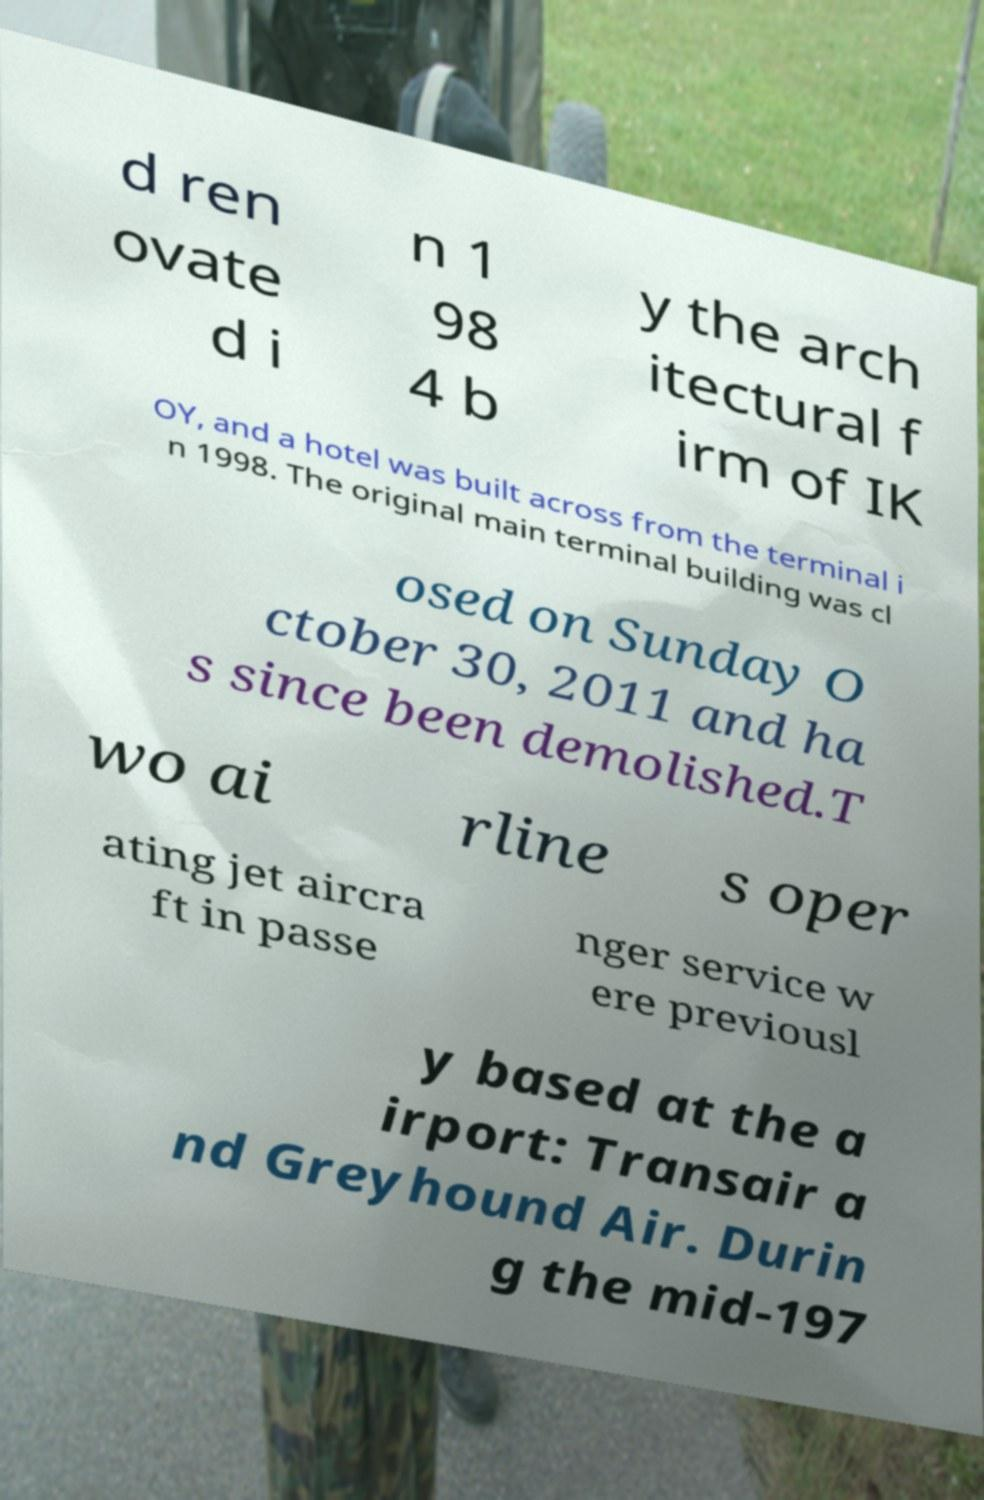Please identify and transcribe the text found in this image. d ren ovate d i n 1 98 4 b y the arch itectural f irm of IK OY, and a hotel was built across from the terminal i n 1998. The original main terminal building was cl osed on Sunday O ctober 30, 2011 and ha s since been demolished.T wo ai rline s oper ating jet aircra ft in passe nger service w ere previousl y based at the a irport: Transair a nd Greyhound Air. Durin g the mid-197 